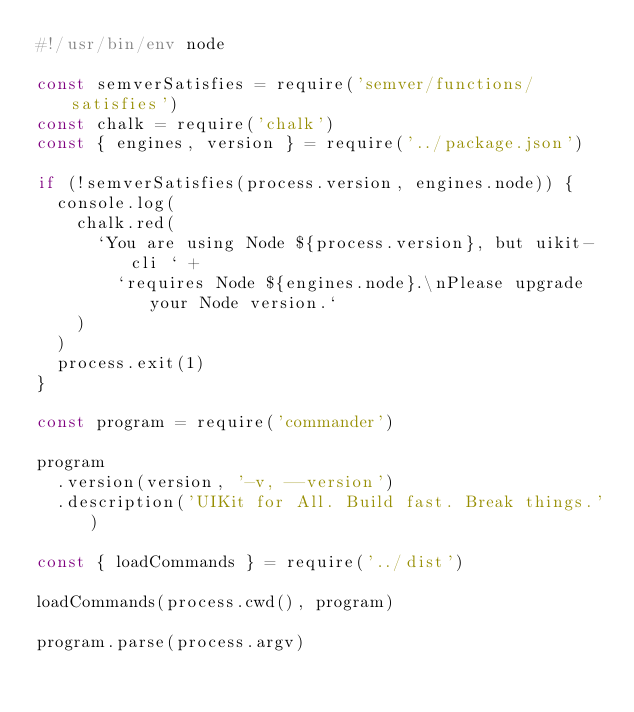<code> <loc_0><loc_0><loc_500><loc_500><_JavaScript_>#!/usr/bin/env node

const semverSatisfies = require('semver/functions/satisfies')
const chalk = require('chalk')
const { engines, version } = require('../package.json')

if (!semverSatisfies(process.version, engines.node)) {
  console.log(
    chalk.red(
      `You are using Node ${process.version}, but uikit-cli ` +
        `requires Node ${engines.node}.\nPlease upgrade your Node version.`
    )
  )
  process.exit(1)
}

const program = require('commander')

program
  .version(version, '-v, --version')
  .description('UIKit for All. Build fast. Break things.')

const { loadCommands } = require('../dist')

loadCommands(process.cwd(), program)

program.parse(process.argv)
</code> 